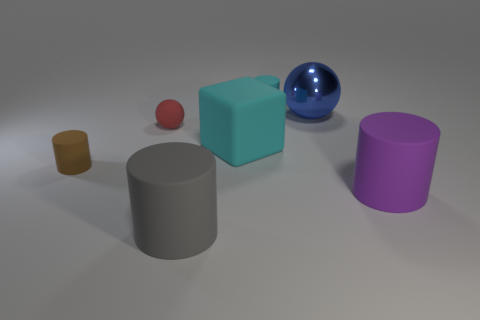The large rubber thing that is in front of the rubber cylinder that is on the right side of the small cylinder that is behind the tiny brown rubber thing is what shape?
Make the answer very short. Cylinder. How many blue objects are shiny objects or big cubes?
Your response must be concise. 1. There is a matte cylinder that is on the left side of the gray matte cylinder; how many small cyan objects are behind it?
Ensure brevity in your answer.  1. Are there any other things of the same color as the large matte cube?
Provide a short and direct response. Yes. There is a big cyan object that is made of the same material as the tiny ball; what is its shape?
Give a very brief answer. Cube. Is the material of the big cylinder to the left of the small cyan matte object the same as the cyan object behind the big cube?
Make the answer very short. Yes. How many objects are large cyan cubes or matte cylinders to the left of the gray matte cylinder?
Your answer should be very brief. 2. Are there any other things that are the same material as the big blue sphere?
Offer a terse response. No. There is a matte thing that is the same color as the big matte block; what shape is it?
Provide a short and direct response. Cylinder. What is the material of the blue thing?
Your answer should be very brief. Metal. 